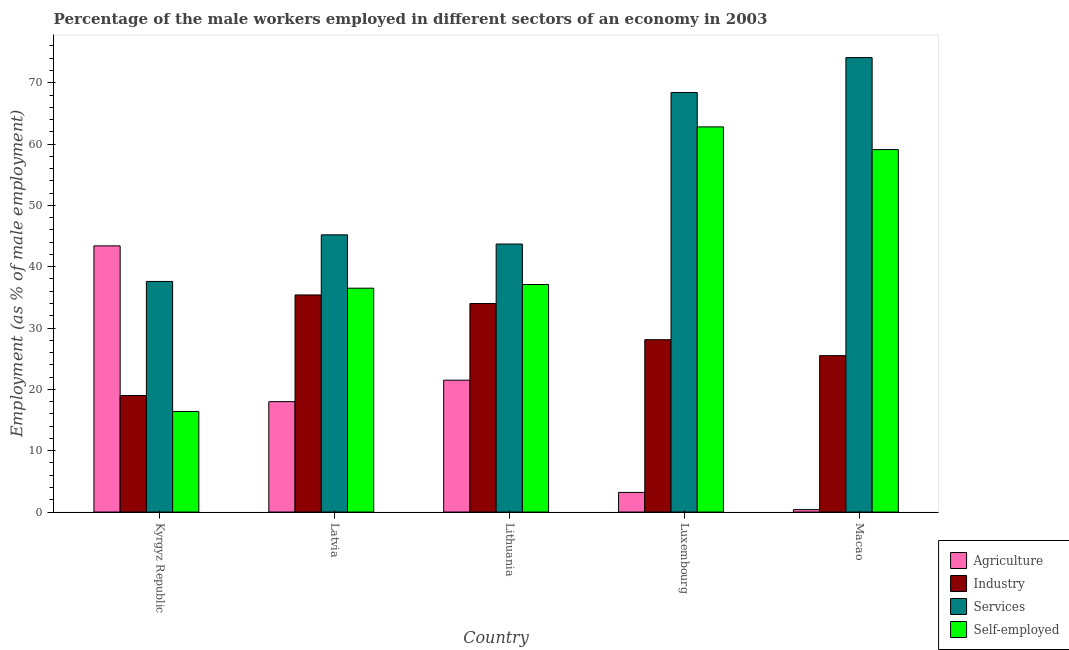How many different coloured bars are there?
Your response must be concise. 4. Are the number of bars per tick equal to the number of legend labels?
Keep it short and to the point. Yes. What is the label of the 2nd group of bars from the left?
Make the answer very short. Latvia. Across all countries, what is the maximum percentage of self employed male workers?
Keep it short and to the point. 62.8. In which country was the percentage of male workers in agriculture maximum?
Provide a short and direct response. Kyrgyz Republic. In which country was the percentage of self employed male workers minimum?
Your answer should be very brief. Kyrgyz Republic. What is the total percentage of self employed male workers in the graph?
Your answer should be compact. 211.9. What is the difference between the percentage of male workers in agriculture in Luxembourg and that in Macao?
Your answer should be very brief. 2.8. What is the difference between the percentage of self employed male workers in Luxembourg and the percentage of male workers in services in Latvia?
Your answer should be very brief. 17.6. What is the average percentage of male workers in services per country?
Your response must be concise. 53.8. What is the difference between the percentage of male workers in industry and percentage of male workers in agriculture in Kyrgyz Republic?
Offer a terse response. -24.4. What is the ratio of the percentage of male workers in agriculture in Latvia to that in Macao?
Your answer should be compact. 45. Is the difference between the percentage of self employed male workers in Kyrgyz Republic and Macao greater than the difference between the percentage of male workers in agriculture in Kyrgyz Republic and Macao?
Offer a very short reply. No. What is the difference between the highest and the second highest percentage of self employed male workers?
Ensure brevity in your answer.  3.7. What is the difference between the highest and the lowest percentage of male workers in services?
Offer a terse response. 36.5. In how many countries, is the percentage of male workers in services greater than the average percentage of male workers in services taken over all countries?
Your answer should be very brief. 2. What does the 1st bar from the left in Macao represents?
Your response must be concise. Agriculture. What does the 4th bar from the right in Lithuania represents?
Provide a succinct answer. Agriculture. Is it the case that in every country, the sum of the percentage of male workers in agriculture and percentage of male workers in industry is greater than the percentage of male workers in services?
Give a very brief answer. No. How many bars are there?
Your response must be concise. 20. Are all the bars in the graph horizontal?
Provide a short and direct response. No. How many countries are there in the graph?
Provide a succinct answer. 5. Are the values on the major ticks of Y-axis written in scientific E-notation?
Your answer should be compact. No. Where does the legend appear in the graph?
Your response must be concise. Bottom right. How are the legend labels stacked?
Offer a very short reply. Vertical. What is the title of the graph?
Your answer should be very brief. Percentage of the male workers employed in different sectors of an economy in 2003. Does "Payroll services" appear as one of the legend labels in the graph?
Provide a succinct answer. No. What is the label or title of the X-axis?
Your answer should be compact. Country. What is the label or title of the Y-axis?
Provide a succinct answer. Employment (as % of male employment). What is the Employment (as % of male employment) in Agriculture in Kyrgyz Republic?
Provide a succinct answer. 43.4. What is the Employment (as % of male employment) in Services in Kyrgyz Republic?
Your response must be concise. 37.6. What is the Employment (as % of male employment) of Self-employed in Kyrgyz Republic?
Ensure brevity in your answer.  16.4. What is the Employment (as % of male employment) of Industry in Latvia?
Your answer should be compact. 35.4. What is the Employment (as % of male employment) of Services in Latvia?
Ensure brevity in your answer.  45.2. What is the Employment (as % of male employment) in Self-employed in Latvia?
Keep it short and to the point. 36.5. What is the Employment (as % of male employment) of Agriculture in Lithuania?
Keep it short and to the point. 21.5. What is the Employment (as % of male employment) of Industry in Lithuania?
Your response must be concise. 34. What is the Employment (as % of male employment) in Services in Lithuania?
Your answer should be compact. 43.7. What is the Employment (as % of male employment) in Self-employed in Lithuania?
Offer a terse response. 37.1. What is the Employment (as % of male employment) of Agriculture in Luxembourg?
Give a very brief answer. 3.2. What is the Employment (as % of male employment) of Industry in Luxembourg?
Offer a terse response. 28.1. What is the Employment (as % of male employment) of Services in Luxembourg?
Ensure brevity in your answer.  68.4. What is the Employment (as % of male employment) of Self-employed in Luxembourg?
Offer a very short reply. 62.8. What is the Employment (as % of male employment) in Agriculture in Macao?
Provide a succinct answer. 0.4. What is the Employment (as % of male employment) in Industry in Macao?
Offer a very short reply. 25.5. What is the Employment (as % of male employment) of Services in Macao?
Offer a very short reply. 74.1. What is the Employment (as % of male employment) of Self-employed in Macao?
Offer a terse response. 59.1. Across all countries, what is the maximum Employment (as % of male employment) of Agriculture?
Your answer should be very brief. 43.4. Across all countries, what is the maximum Employment (as % of male employment) in Industry?
Your response must be concise. 35.4. Across all countries, what is the maximum Employment (as % of male employment) of Services?
Your answer should be compact. 74.1. Across all countries, what is the maximum Employment (as % of male employment) in Self-employed?
Your answer should be very brief. 62.8. Across all countries, what is the minimum Employment (as % of male employment) in Agriculture?
Make the answer very short. 0.4. Across all countries, what is the minimum Employment (as % of male employment) in Services?
Give a very brief answer. 37.6. Across all countries, what is the minimum Employment (as % of male employment) in Self-employed?
Make the answer very short. 16.4. What is the total Employment (as % of male employment) in Agriculture in the graph?
Give a very brief answer. 86.5. What is the total Employment (as % of male employment) in Industry in the graph?
Give a very brief answer. 142. What is the total Employment (as % of male employment) of Services in the graph?
Offer a very short reply. 269. What is the total Employment (as % of male employment) of Self-employed in the graph?
Provide a short and direct response. 211.9. What is the difference between the Employment (as % of male employment) in Agriculture in Kyrgyz Republic and that in Latvia?
Your response must be concise. 25.4. What is the difference between the Employment (as % of male employment) in Industry in Kyrgyz Republic and that in Latvia?
Give a very brief answer. -16.4. What is the difference between the Employment (as % of male employment) of Self-employed in Kyrgyz Republic and that in Latvia?
Offer a terse response. -20.1. What is the difference between the Employment (as % of male employment) in Agriculture in Kyrgyz Republic and that in Lithuania?
Your response must be concise. 21.9. What is the difference between the Employment (as % of male employment) of Industry in Kyrgyz Republic and that in Lithuania?
Your answer should be very brief. -15. What is the difference between the Employment (as % of male employment) in Self-employed in Kyrgyz Republic and that in Lithuania?
Your answer should be compact. -20.7. What is the difference between the Employment (as % of male employment) in Agriculture in Kyrgyz Republic and that in Luxembourg?
Your answer should be very brief. 40.2. What is the difference between the Employment (as % of male employment) in Services in Kyrgyz Republic and that in Luxembourg?
Ensure brevity in your answer.  -30.8. What is the difference between the Employment (as % of male employment) of Self-employed in Kyrgyz Republic and that in Luxembourg?
Your response must be concise. -46.4. What is the difference between the Employment (as % of male employment) of Industry in Kyrgyz Republic and that in Macao?
Keep it short and to the point. -6.5. What is the difference between the Employment (as % of male employment) in Services in Kyrgyz Republic and that in Macao?
Offer a very short reply. -36.5. What is the difference between the Employment (as % of male employment) in Self-employed in Kyrgyz Republic and that in Macao?
Offer a very short reply. -42.7. What is the difference between the Employment (as % of male employment) of Industry in Latvia and that in Lithuania?
Provide a short and direct response. 1.4. What is the difference between the Employment (as % of male employment) of Services in Latvia and that in Lithuania?
Offer a very short reply. 1.5. What is the difference between the Employment (as % of male employment) of Self-employed in Latvia and that in Lithuania?
Your answer should be very brief. -0.6. What is the difference between the Employment (as % of male employment) of Agriculture in Latvia and that in Luxembourg?
Give a very brief answer. 14.8. What is the difference between the Employment (as % of male employment) of Services in Latvia and that in Luxembourg?
Your answer should be very brief. -23.2. What is the difference between the Employment (as % of male employment) in Self-employed in Latvia and that in Luxembourg?
Make the answer very short. -26.3. What is the difference between the Employment (as % of male employment) of Agriculture in Latvia and that in Macao?
Your answer should be very brief. 17.6. What is the difference between the Employment (as % of male employment) in Services in Latvia and that in Macao?
Offer a terse response. -28.9. What is the difference between the Employment (as % of male employment) in Self-employed in Latvia and that in Macao?
Keep it short and to the point. -22.6. What is the difference between the Employment (as % of male employment) in Services in Lithuania and that in Luxembourg?
Keep it short and to the point. -24.7. What is the difference between the Employment (as % of male employment) in Self-employed in Lithuania and that in Luxembourg?
Provide a short and direct response. -25.7. What is the difference between the Employment (as % of male employment) of Agriculture in Lithuania and that in Macao?
Ensure brevity in your answer.  21.1. What is the difference between the Employment (as % of male employment) in Industry in Lithuania and that in Macao?
Offer a very short reply. 8.5. What is the difference between the Employment (as % of male employment) of Services in Lithuania and that in Macao?
Your response must be concise. -30.4. What is the difference between the Employment (as % of male employment) in Self-employed in Lithuania and that in Macao?
Keep it short and to the point. -22. What is the difference between the Employment (as % of male employment) in Agriculture in Luxembourg and that in Macao?
Provide a short and direct response. 2.8. What is the difference between the Employment (as % of male employment) in Self-employed in Luxembourg and that in Macao?
Your response must be concise. 3.7. What is the difference between the Employment (as % of male employment) of Agriculture in Kyrgyz Republic and the Employment (as % of male employment) of Industry in Latvia?
Make the answer very short. 8. What is the difference between the Employment (as % of male employment) of Agriculture in Kyrgyz Republic and the Employment (as % of male employment) of Services in Latvia?
Ensure brevity in your answer.  -1.8. What is the difference between the Employment (as % of male employment) in Industry in Kyrgyz Republic and the Employment (as % of male employment) in Services in Latvia?
Your answer should be compact. -26.2. What is the difference between the Employment (as % of male employment) of Industry in Kyrgyz Republic and the Employment (as % of male employment) of Self-employed in Latvia?
Keep it short and to the point. -17.5. What is the difference between the Employment (as % of male employment) of Industry in Kyrgyz Republic and the Employment (as % of male employment) of Services in Lithuania?
Offer a terse response. -24.7. What is the difference between the Employment (as % of male employment) of Industry in Kyrgyz Republic and the Employment (as % of male employment) of Self-employed in Lithuania?
Your answer should be compact. -18.1. What is the difference between the Employment (as % of male employment) in Services in Kyrgyz Republic and the Employment (as % of male employment) in Self-employed in Lithuania?
Offer a terse response. 0.5. What is the difference between the Employment (as % of male employment) of Agriculture in Kyrgyz Republic and the Employment (as % of male employment) of Self-employed in Luxembourg?
Offer a very short reply. -19.4. What is the difference between the Employment (as % of male employment) in Industry in Kyrgyz Republic and the Employment (as % of male employment) in Services in Luxembourg?
Offer a very short reply. -49.4. What is the difference between the Employment (as % of male employment) of Industry in Kyrgyz Republic and the Employment (as % of male employment) of Self-employed in Luxembourg?
Your answer should be compact. -43.8. What is the difference between the Employment (as % of male employment) of Services in Kyrgyz Republic and the Employment (as % of male employment) of Self-employed in Luxembourg?
Keep it short and to the point. -25.2. What is the difference between the Employment (as % of male employment) of Agriculture in Kyrgyz Republic and the Employment (as % of male employment) of Services in Macao?
Provide a short and direct response. -30.7. What is the difference between the Employment (as % of male employment) of Agriculture in Kyrgyz Republic and the Employment (as % of male employment) of Self-employed in Macao?
Offer a very short reply. -15.7. What is the difference between the Employment (as % of male employment) of Industry in Kyrgyz Republic and the Employment (as % of male employment) of Services in Macao?
Give a very brief answer. -55.1. What is the difference between the Employment (as % of male employment) in Industry in Kyrgyz Republic and the Employment (as % of male employment) in Self-employed in Macao?
Your answer should be very brief. -40.1. What is the difference between the Employment (as % of male employment) of Services in Kyrgyz Republic and the Employment (as % of male employment) of Self-employed in Macao?
Give a very brief answer. -21.5. What is the difference between the Employment (as % of male employment) of Agriculture in Latvia and the Employment (as % of male employment) of Industry in Lithuania?
Your answer should be compact. -16. What is the difference between the Employment (as % of male employment) of Agriculture in Latvia and the Employment (as % of male employment) of Services in Lithuania?
Keep it short and to the point. -25.7. What is the difference between the Employment (as % of male employment) of Agriculture in Latvia and the Employment (as % of male employment) of Self-employed in Lithuania?
Your answer should be very brief. -19.1. What is the difference between the Employment (as % of male employment) of Industry in Latvia and the Employment (as % of male employment) of Services in Lithuania?
Provide a short and direct response. -8.3. What is the difference between the Employment (as % of male employment) in Industry in Latvia and the Employment (as % of male employment) in Self-employed in Lithuania?
Make the answer very short. -1.7. What is the difference between the Employment (as % of male employment) in Agriculture in Latvia and the Employment (as % of male employment) in Industry in Luxembourg?
Provide a short and direct response. -10.1. What is the difference between the Employment (as % of male employment) in Agriculture in Latvia and the Employment (as % of male employment) in Services in Luxembourg?
Your response must be concise. -50.4. What is the difference between the Employment (as % of male employment) of Agriculture in Latvia and the Employment (as % of male employment) of Self-employed in Luxembourg?
Make the answer very short. -44.8. What is the difference between the Employment (as % of male employment) in Industry in Latvia and the Employment (as % of male employment) in Services in Luxembourg?
Provide a succinct answer. -33. What is the difference between the Employment (as % of male employment) of Industry in Latvia and the Employment (as % of male employment) of Self-employed in Luxembourg?
Ensure brevity in your answer.  -27.4. What is the difference between the Employment (as % of male employment) in Services in Latvia and the Employment (as % of male employment) in Self-employed in Luxembourg?
Provide a succinct answer. -17.6. What is the difference between the Employment (as % of male employment) of Agriculture in Latvia and the Employment (as % of male employment) of Services in Macao?
Offer a very short reply. -56.1. What is the difference between the Employment (as % of male employment) in Agriculture in Latvia and the Employment (as % of male employment) in Self-employed in Macao?
Your answer should be very brief. -41.1. What is the difference between the Employment (as % of male employment) in Industry in Latvia and the Employment (as % of male employment) in Services in Macao?
Keep it short and to the point. -38.7. What is the difference between the Employment (as % of male employment) in Industry in Latvia and the Employment (as % of male employment) in Self-employed in Macao?
Give a very brief answer. -23.7. What is the difference between the Employment (as % of male employment) in Services in Latvia and the Employment (as % of male employment) in Self-employed in Macao?
Your answer should be very brief. -13.9. What is the difference between the Employment (as % of male employment) in Agriculture in Lithuania and the Employment (as % of male employment) in Industry in Luxembourg?
Provide a short and direct response. -6.6. What is the difference between the Employment (as % of male employment) in Agriculture in Lithuania and the Employment (as % of male employment) in Services in Luxembourg?
Offer a terse response. -46.9. What is the difference between the Employment (as % of male employment) of Agriculture in Lithuania and the Employment (as % of male employment) of Self-employed in Luxembourg?
Your answer should be compact. -41.3. What is the difference between the Employment (as % of male employment) of Industry in Lithuania and the Employment (as % of male employment) of Services in Luxembourg?
Provide a short and direct response. -34.4. What is the difference between the Employment (as % of male employment) of Industry in Lithuania and the Employment (as % of male employment) of Self-employed in Luxembourg?
Your answer should be very brief. -28.8. What is the difference between the Employment (as % of male employment) of Services in Lithuania and the Employment (as % of male employment) of Self-employed in Luxembourg?
Offer a very short reply. -19.1. What is the difference between the Employment (as % of male employment) of Agriculture in Lithuania and the Employment (as % of male employment) of Industry in Macao?
Offer a very short reply. -4. What is the difference between the Employment (as % of male employment) in Agriculture in Lithuania and the Employment (as % of male employment) in Services in Macao?
Provide a short and direct response. -52.6. What is the difference between the Employment (as % of male employment) in Agriculture in Lithuania and the Employment (as % of male employment) in Self-employed in Macao?
Make the answer very short. -37.6. What is the difference between the Employment (as % of male employment) in Industry in Lithuania and the Employment (as % of male employment) in Services in Macao?
Provide a succinct answer. -40.1. What is the difference between the Employment (as % of male employment) in Industry in Lithuania and the Employment (as % of male employment) in Self-employed in Macao?
Offer a terse response. -25.1. What is the difference between the Employment (as % of male employment) of Services in Lithuania and the Employment (as % of male employment) of Self-employed in Macao?
Make the answer very short. -15.4. What is the difference between the Employment (as % of male employment) of Agriculture in Luxembourg and the Employment (as % of male employment) of Industry in Macao?
Give a very brief answer. -22.3. What is the difference between the Employment (as % of male employment) in Agriculture in Luxembourg and the Employment (as % of male employment) in Services in Macao?
Keep it short and to the point. -70.9. What is the difference between the Employment (as % of male employment) in Agriculture in Luxembourg and the Employment (as % of male employment) in Self-employed in Macao?
Ensure brevity in your answer.  -55.9. What is the difference between the Employment (as % of male employment) of Industry in Luxembourg and the Employment (as % of male employment) of Services in Macao?
Your response must be concise. -46. What is the difference between the Employment (as % of male employment) in Industry in Luxembourg and the Employment (as % of male employment) in Self-employed in Macao?
Your answer should be compact. -31. What is the difference between the Employment (as % of male employment) in Services in Luxembourg and the Employment (as % of male employment) in Self-employed in Macao?
Your response must be concise. 9.3. What is the average Employment (as % of male employment) in Agriculture per country?
Your response must be concise. 17.3. What is the average Employment (as % of male employment) in Industry per country?
Give a very brief answer. 28.4. What is the average Employment (as % of male employment) of Services per country?
Make the answer very short. 53.8. What is the average Employment (as % of male employment) of Self-employed per country?
Offer a very short reply. 42.38. What is the difference between the Employment (as % of male employment) in Agriculture and Employment (as % of male employment) in Industry in Kyrgyz Republic?
Your answer should be compact. 24.4. What is the difference between the Employment (as % of male employment) in Agriculture and Employment (as % of male employment) in Self-employed in Kyrgyz Republic?
Keep it short and to the point. 27. What is the difference between the Employment (as % of male employment) of Industry and Employment (as % of male employment) of Services in Kyrgyz Republic?
Offer a terse response. -18.6. What is the difference between the Employment (as % of male employment) of Industry and Employment (as % of male employment) of Self-employed in Kyrgyz Republic?
Keep it short and to the point. 2.6. What is the difference between the Employment (as % of male employment) of Services and Employment (as % of male employment) of Self-employed in Kyrgyz Republic?
Provide a succinct answer. 21.2. What is the difference between the Employment (as % of male employment) in Agriculture and Employment (as % of male employment) in Industry in Latvia?
Ensure brevity in your answer.  -17.4. What is the difference between the Employment (as % of male employment) of Agriculture and Employment (as % of male employment) of Services in Latvia?
Offer a very short reply. -27.2. What is the difference between the Employment (as % of male employment) in Agriculture and Employment (as % of male employment) in Self-employed in Latvia?
Offer a terse response. -18.5. What is the difference between the Employment (as % of male employment) of Industry and Employment (as % of male employment) of Services in Latvia?
Provide a succinct answer. -9.8. What is the difference between the Employment (as % of male employment) in Services and Employment (as % of male employment) in Self-employed in Latvia?
Your answer should be compact. 8.7. What is the difference between the Employment (as % of male employment) in Agriculture and Employment (as % of male employment) in Industry in Lithuania?
Provide a short and direct response. -12.5. What is the difference between the Employment (as % of male employment) in Agriculture and Employment (as % of male employment) in Services in Lithuania?
Your response must be concise. -22.2. What is the difference between the Employment (as % of male employment) of Agriculture and Employment (as % of male employment) of Self-employed in Lithuania?
Your answer should be compact. -15.6. What is the difference between the Employment (as % of male employment) of Services and Employment (as % of male employment) of Self-employed in Lithuania?
Offer a very short reply. 6.6. What is the difference between the Employment (as % of male employment) in Agriculture and Employment (as % of male employment) in Industry in Luxembourg?
Offer a terse response. -24.9. What is the difference between the Employment (as % of male employment) in Agriculture and Employment (as % of male employment) in Services in Luxembourg?
Offer a terse response. -65.2. What is the difference between the Employment (as % of male employment) in Agriculture and Employment (as % of male employment) in Self-employed in Luxembourg?
Provide a short and direct response. -59.6. What is the difference between the Employment (as % of male employment) of Industry and Employment (as % of male employment) of Services in Luxembourg?
Ensure brevity in your answer.  -40.3. What is the difference between the Employment (as % of male employment) in Industry and Employment (as % of male employment) in Self-employed in Luxembourg?
Ensure brevity in your answer.  -34.7. What is the difference between the Employment (as % of male employment) of Agriculture and Employment (as % of male employment) of Industry in Macao?
Keep it short and to the point. -25.1. What is the difference between the Employment (as % of male employment) of Agriculture and Employment (as % of male employment) of Services in Macao?
Your answer should be very brief. -73.7. What is the difference between the Employment (as % of male employment) of Agriculture and Employment (as % of male employment) of Self-employed in Macao?
Provide a short and direct response. -58.7. What is the difference between the Employment (as % of male employment) in Industry and Employment (as % of male employment) in Services in Macao?
Give a very brief answer. -48.6. What is the difference between the Employment (as % of male employment) of Industry and Employment (as % of male employment) of Self-employed in Macao?
Make the answer very short. -33.6. What is the ratio of the Employment (as % of male employment) of Agriculture in Kyrgyz Republic to that in Latvia?
Offer a very short reply. 2.41. What is the ratio of the Employment (as % of male employment) in Industry in Kyrgyz Republic to that in Latvia?
Offer a terse response. 0.54. What is the ratio of the Employment (as % of male employment) in Services in Kyrgyz Republic to that in Latvia?
Make the answer very short. 0.83. What is the ratio of the Employment (as % of male employment) of Self-employed in Kyrgyz Republic to that in Latvia?
Provide a succinct answer. 0.45. What is the ratio of the Employment (as % of male employment) in Agriculture in Kyrgyz Republic to that in Lithuania?
Ensure brevity in your answer.  2.02. What is the ratio of the Employment (as % of male employment) in Industry in Kyrgyz Republic to that in Lithuania?
Offer a very short reply. 0.56. What is the ratio of the Employment (as % of male employment) in Services in Kyrgyz Republic to that in Lithuania?
Offer a terse response. 0.86. What is the ratio of the Employment (as % of male employment) in Self-employed in Kyrgyz Republic to that in Lithuania?
Offer a terse response. 0.44. What is the ratio of the Employment (as % of male employment) in Agriculture in Kyrgyz Republic to that in Luxembourg?
Provide a succinct answer. 13.56. What is the ratio of the Employment (as % of male employment) of Industry in Kyrgyz Republic to that in Luxembourg?
Your answer should be compact. 0.68. What is the ratio of the Employment (as % of male employment) of Services in Kyrgyz Republic to that in Luxembourg?
Provide a short and direct response. 0.55. What is the ratio of the Employment (as % of male employment) of Self-employed in Kyrgyz Republic to that in Luxembourg?
Provide a succinct answer. 0.26. What is the ratio of the Employment (as % of male employment) of Agriculture in Kyrgyz Republic to that in Macao?
Offer a very short reply. 108.5. What is the ratio of the Employment (as % of male employment) in Industry in Kyrgyz Republic to that in Macao?
Make the answer very short. 0.75. What is the ratio of the Employment (as % of male employment) of Services in Kyrgyz Republic to that in Macao?
Keep it short and to the point. 0.51. What is the ratio of the Employment (as % of male employment) in Self-employed in Kyrgyz Republic to that in Macao?
Keep it short and to the point. 0.28. What is the ratio of the Employment (as % of male employment) in Agriculture in Latvia to that in Lithuania?
Offer a very short reply. 0.84. What is the ratio of the Employment (as % of male employment) in Industry in Latvia to that in Lithuania?
Your answer should be compact. 1.04. What is the ratio of the Employment (as % of male employment) of Services in Latvia to that in Lithuania?
Make the answer very short. 1.03. What is the ratio of the Employment (as % of male employment) in Self-employed in Latvia to that in Lithuania?
Your answer should be very brief. 0.98. What is the ratio of the Employment (as % of male employment) of Agriculture in Latvia to that in Luxembourg?
Offer a terse response. 5.62. What is the ratio of the Employment (as % of male employment) in Industry in Latvia to that in Luxembourg?
Provide a succinct answer. 1.26. What is the ratio of the Employment (as % of male employment) of Services in Latvia to that in Luxembourg?
Your answer should be compact. 0.66. What is the ratio of the Employment (as % of male employment) of Self-employed in Latvia to that in Luxembourg?
Provide a succinct answer. 0.58. What is the ratio of the Employment (as % of male employment) of Agriculture in Latvia to that in Macao?
Ensure brevity in your answer.  45. What is the ratio of the Employment (as % of male employment) in Industry in Latvia to that in Macao?
Give a very brief answer. 1.39. What is the ratio of the Employment (as % of male employment) in Services in Latvia to that in Macao?
Offer a very short reply. 0.61. What is the ratio of the Employment (as % of male employment) in Self-employed in Latvia to that in Macao?
Give a very brief answer. 0.62. What is the ratio of the Employment (as % of male employment) in Agriculture in Lithuania to that in Luxembourg?
Offer a very short reply. 6.72. What is the ratio of the Employment (as % of male employment) of Industry in Lithuania to that in Luxembourg?
Offer a terse response. 1.21. What is the ratio of the Employment (as % of male employment) in Services in Lithuania to that in Luxembourg?
Ensure brevity in your answer.  0.64. What is the ratio of the Employment (as % of male employment) of Self-employed in Lithuania to that in Luxembourg?
Ensure brevity in your answer.  0.59. What is the ratio of the Employment (as % of male employment) of Agriculture in Lithuania to that in Macao?
Provide a short and direct response. 53.75. What is the ratio of the Employment (as % of male employment) in Services in Lithuania to that in Macao?
Provide a short and direct response. 0.59. What is the ratio of the Employment (as % of male employment) in Self-employed in Lithuania to that in Macao?
Provide a short and direct response. 0.63. What is the ratio of the Employment (as % of male employment) in Agriculture in Luxembourg to that in Macao?
Provide a short and direct response. 8. What is the ratio of the Employment (as % of male employment) in Industry in Luxembourg to that in Macao?
Offer a terse response. 1.1. What is the ratio of the Employment (as % of male employment) in Self-employed in Luxembourg to that in Macao?
Make the answer very short. 1.06. What is the difference between the highest and the second highest Employment (as % of male employment) of Agriculture?
Ensure brevity in your answer.  21.9. What is the difference between the highest and the second highest Employment (as % of male employment) of Self-employed?
Give a very brief answer. 3.7. What is the difference between the highest and the lowest Employment (as % of male employment) of Agriculture?
Ensure brevity in your answer.  43. What is the difference between the highest and the lowest Employment (as % of male employment) in Services?
Your answer should be compact. 36.5. What is the difference between the highest and the lowest Employment (as % of male employment) in Self-employed?
Your answer should be very brief. 46.4. 